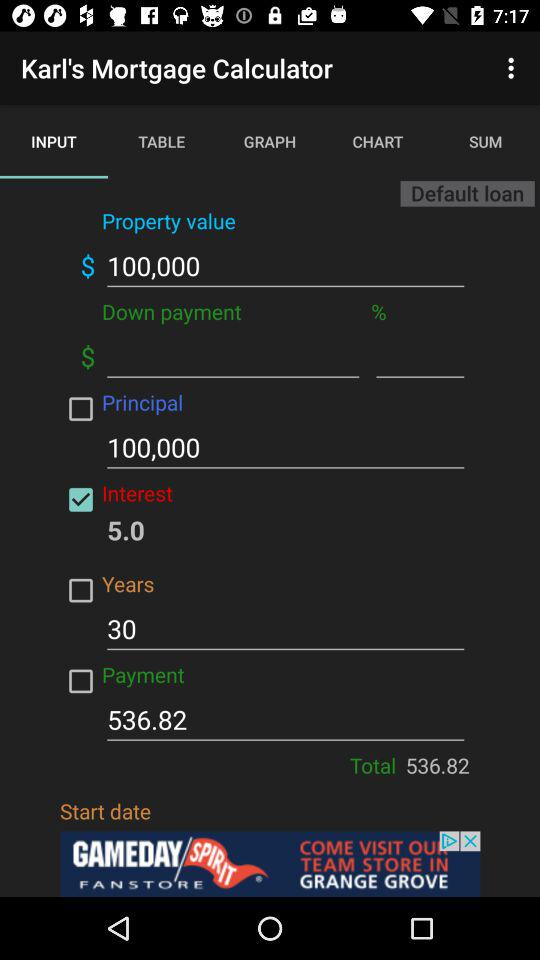Which option is selected for Karl's Mortgage Calculator? The selected option for Karl's Mortgage Calculator is "INPUT". 